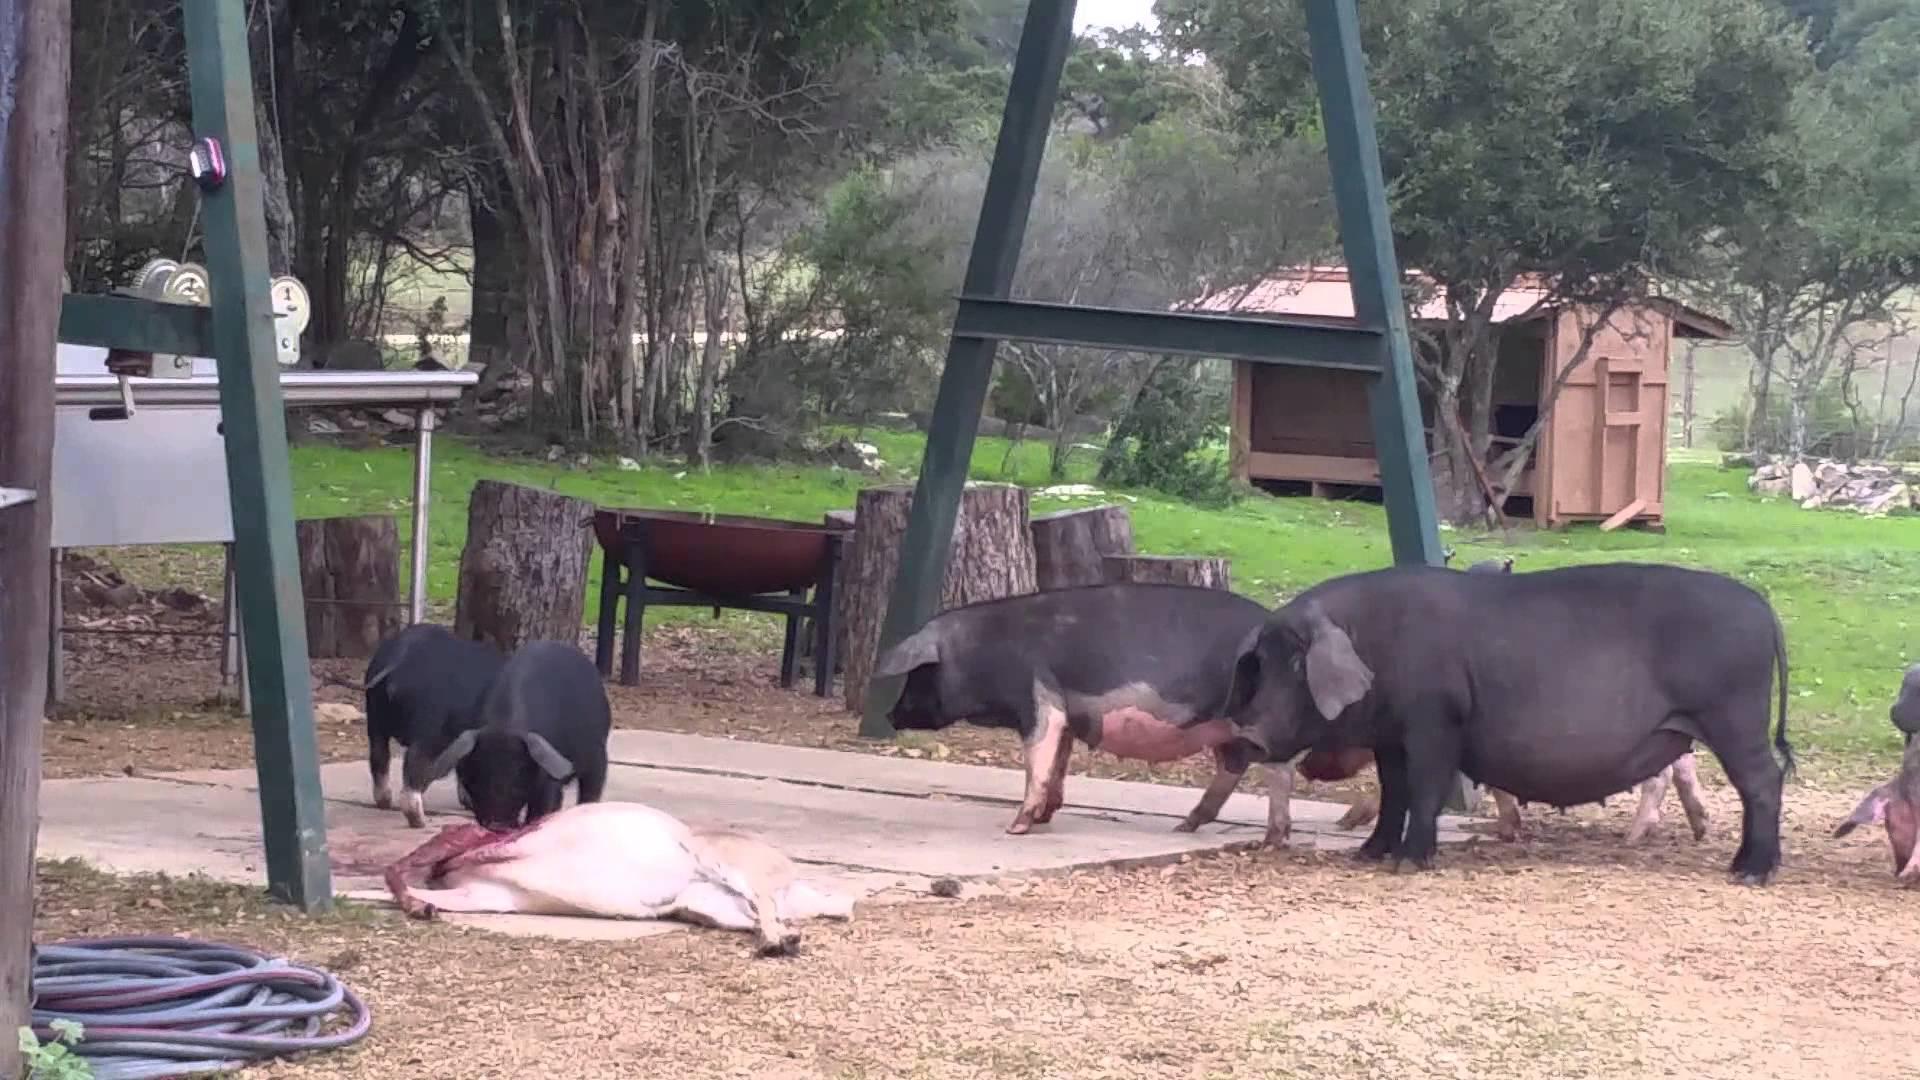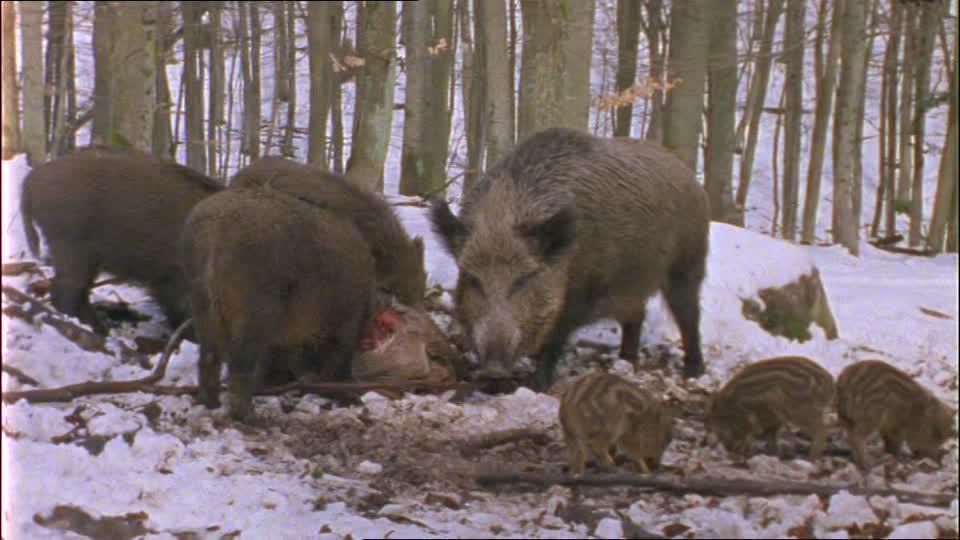The first image is the image on the left, the second image is the image on the right. Evaluate the accuracy of this statement regarding the images: "Some of the pigs are standing in snow.". Is it true? Answer yes or no. Yes. The first image is the image on the left, the second image is the image on the right. Given the left and right images, does the statement "One image shows several striped wild boar piglets sharing a meaty meal with their elders." hold true? Answer yes or no. Yes. 